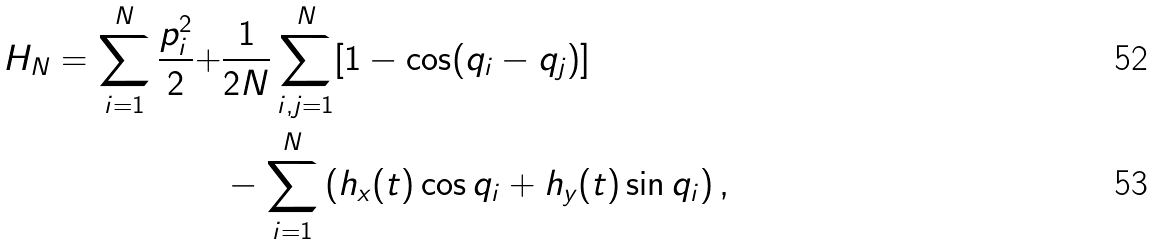Convert formula to latex. <formula><loc_0><loc_0><loc_500><loc_500>H _ { N } = \sum _ { i = 1 } ^ { N } \frac { p _ { i } ^ { 2 } } { 2 } + & \frac { 1 } { 2 N } \sum _ { i , j = 1 } ^ { N } [ 1 - \cos ( q _ { i } - q _ { j } ) ] \\ & - \sum _ { i = 1 } ^ { N } \left ( h _ { x } ( t ) \cos q _ { i } + h _ { y } ( t ) \sin q _ { i } \right ) ,</formula> 